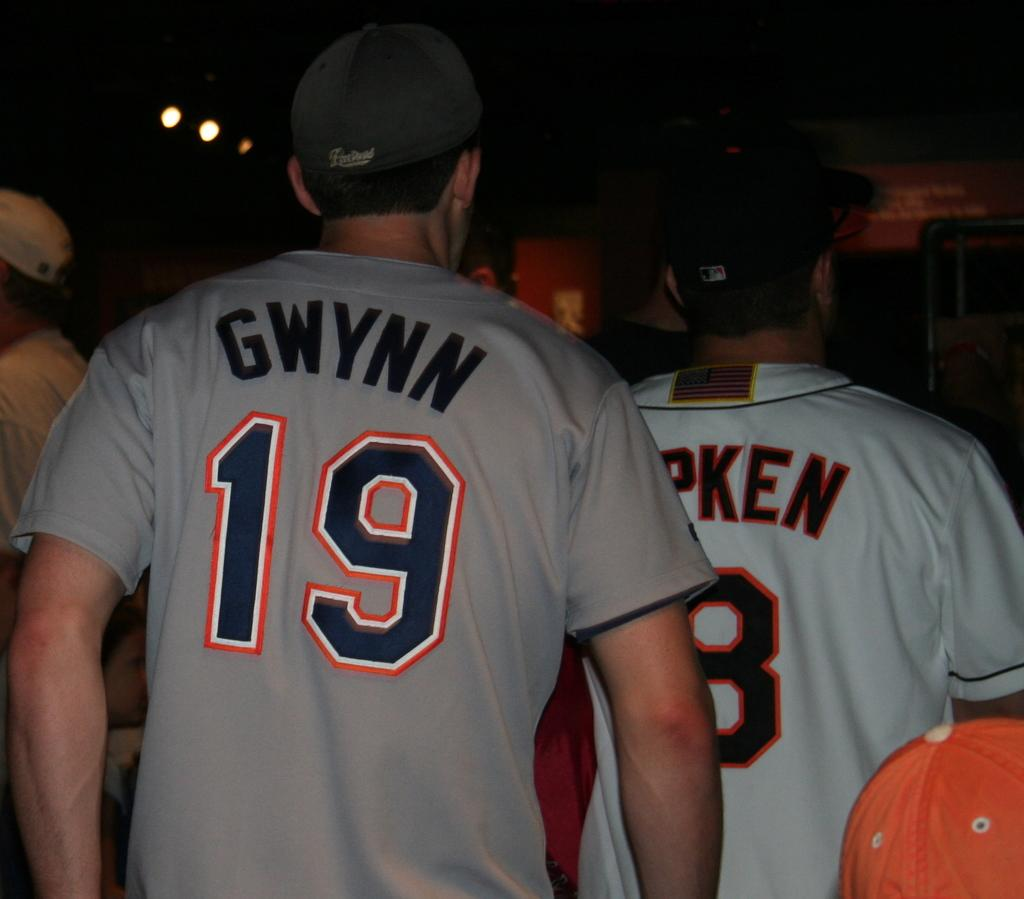<image>
Render a clear and concise summary of the photo. Fans of Tony Gwynn and Cal Ripken walk among a crowd of people. 